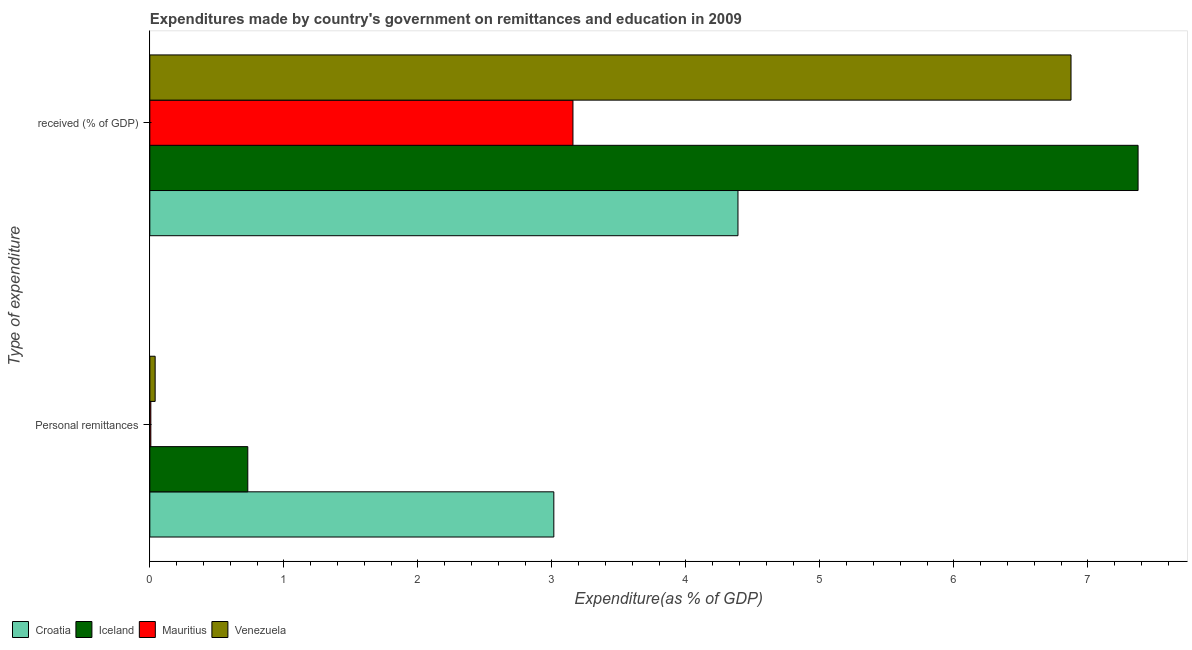How many bars are there on the 1st tick from the top?
Ensure brevity in your answer.  4. What is the label of the 2nd group of bars from the top?
Give a very brief answer. Personal remittances. What is the expenditure in education in Iceland?
Offer a very short reply. 7.38. Across all countries, what is the maximum expenditure in personal remittances?
Your answer should be compact. 3.01. Across all countries, what is the minimum expenditure in education?
Keep it short and to the point. 3.16. In which country was the expenditure in personal remittances minimum?
Provide a succinct answer. Mauritius. What is the total expenditure in education in the graph?
Provide a short and direct response. 21.8. What is the difference between the expenditure in personal remittances in Croatia and that in Venezuela?
Keep it short and to the point. 2.98. What is the difference between the expenditure in education in Croatia and the expenditure in personal remittances in Venezuela?
Make the answer very short. 4.35. What is the average expenditure in personal remittances per country?
Ensure brevity in your answer.  0.95. What is the difference between the expenditure in education and expenditure in personal remittances in Mauritius?
Make the answer very short. 3.15. In how many countries, is the expenditure in education greater than 4.2 %?
Keep it short and to the point. 3. What is the ratio of the expenditure in personal remittances in Venezuela to that in Mauritius?
Your response must be concise. 5.32. In how many countries, is the expenditure in education greater than the average expenditure in education taken over all countries?
Offer a very short reply. 2. What does the 3rd bar from the top in Personal remittances represents?
Your answer should be compact. Iceland. How many bars are there?
Your answer should be compact. 8. Are all the bars in the graph horizontal?
Ensure brevity in your answer.  Yes. Are the values on the major ticks of X-axis written in scientific E-notation?
Keep it short and to the point. No. Does the graph contain grids?
Offer a very short reply. No. Where does the legend appear in the graph?
Offer a terse response. Bottom left. How many legend labels are there?
Provide a succinct answer. 4. How are the legend labels stacked?
Offer a very short reply. Horizontal. What is the title of the graph?
Give a very brief answer. Expenditures made by country's government on remittances and education in 2009. Does "Latvia" appear as one of the legend labels in the graph?
Your answer should be compact. No. What is the label or title of the X-axis?
Keep it short and to the point. Expenditure(as % of GDP). What is the label or title of the Y-axis?
Ensure brevity in your answer.  Type of expenditure. What is the Expenditure(as % of GDP) in Croatia in Personal remittances?
Give a very brief answer. 3.01. What is the Expenditure(as % of GDP) of Iceland in Personal remittances?
Give a very brief answer. 0.73. What is the Expenditure(as % of GDP) of Mauritius in Personal remittances?
Offer a terse response. 0.01. What is the Expenditure(as % of GDP) of Venezuela in Personal remittances?
Make the answer very short. 0.04. What is the Expenditure(as % of GDP) in Croatia in  received (% of GDP)?
Offer a very short reply. 4.39. What is the Expenditure(as % of GDP) in Iceland in  received (% of GDP)?
Make the answer very short. 7.38. What is the Expenditure(as % of GDP) in Mauritius in  received (% of GDP)?
Keep it short and to the point. 3.16. What is the Expenditure(as % of GDP) in Venezuela in  received (% of GDP)?
Offer a very short reply. 6.87. Across all Type of expenditure, what is the maximum Expenditure(as % of GDP) of Croatia?
Your response must be concise. 4.39. Across all Type of expenditure, what is the maximum Expenditure(as % of GDP) of Iceland?
Make the answer very short. 7.38. Across all Type of expenditure, what is the maximum Expenditure(as % of GDP) of Mauritius?
Your answer should be compact. 3.16. Across all Type of expenditure, what is the maximum Expenditure(as % of GDP) in Venezuela?
Ensure brevity in your answer.  6.87. Across all Type of expenditure, what is the minimum Expenditure(as % of GDP) in Croatia?
Keep it short and to the point. 3.01. Across all Type of expenditure, what is the minimum Expenditure(as % of GDP) in Iceland?
Offer a terse response. 0.73. Across all Type of expenditure, what is the minimum Expenditure(as % of GDP) of Mauritius?
Your answer should be very brief. 0.01. Across all Type of expenditure, what is the minimum Expenditure(as % of GDP) in Venezuela?
Provide a succinct answer. 0.04. What is the total Expenditure(as % of GDP) in Croatia in the graph?
Keep it short and to the point. 7.4. What is the total Expenditure(as % of GDP) of Iceland in the graph?
Offer a very short reply. 8.11. What is the total Expenditure(as % of GDP) in Mauritius in the graph?
Your response must be concise. 3.17. What is the total Expenditure(as % of GDP) in Venezuela in the graph?
Ensure brevity in your answer.  6.91. What is the difference between the Expenditure(as % of GDP) in Croatia in Personal remittances and that in  received (% of GDP)?
Offer a terse response. -1.37. What is the difference between the Expenditure(as % of GDP) in Iceland in Personal remittances and that in  received (% of GDP)?
Offer a very short reply. -6.64. What is the difference between the Expenditure(as % of GDP) of Mauritius in Personal remittances and that in  received (% of GDP)?
Your answer should be very brief. -3.15. What is the difference between the Expenditure(as % of GDP) in Venezuela in Personal remittances and that in  received (% of GDP)?
Provide a succinct answer. -6.83. What is the difference between the Expenditure(as % of GDP) of Croatia in Personal remittances and the Expenditure(as % of GDP) of Iceland in  received (% of GDP)?
Make the answer very short. -4.36. What is the difference between the Expenditure(as % of GDP) in Croatia in Personal remittances and the Expenditure(as % of GDP) in Mauritius in  received (% of GDP)?
Your response must be concise. -0.14. What is the difference between the Expenditure(as % of GDP) of Croatia in Personal remittances and the Expenditure(as % of GDP) of Venezuela in  received (% of GDP)?
Ensure brevity in your answer.  -3.86. What is the difference between the Expenditure(as % of GDP) in Iceland in Personal remittances and the Expenditure(as % of GDP) in Mauritius in  received (% of GDP)?
Give a very brief answer. -2.43. What is the difference between the Expenditure(as % of GDP) of Iceland in Personal remittances and the Expenditure(as % of GDP) of Venezuela in  received (% of GDP)?
Provide a short and direct response. -6.14. What is the difference between the Expenditure(as % of GDP) of Mauritius in Personal remittances and the Expenditure(as % of GDP) of Venezuela in  received (% of GDP)?
Your answer should be very brief. -6.87. What is the average Expenditure(as % of GDP) of Croatia per Type of expenditure?
Your answer should be very brief. 3.7. What is the average Expenditure(as % of GDP) of Iceland per Type of expenditure?
Offer a terse response. 4.05. What is the average Expenditure(as % of GDP) of Mauritius per Type of expenditure?
Your answer should be compact. 1.58. What is the average Expenditure(as % of GDP) of Venezuela per Type of expenditure?
Your answer should be compact. 3.46. What is the difference between the Expenditure(as % of GDP) of Croatia and Expenditure(as % of GDP) of Iceland in Personal remittances?
Your answer should be compact. 2.28. What is the difference between the Expenditure(as % of GDP) in Croatia and Expenditure(as % of GDP) in Mauritius in Personal remittances?
Offer a very short reply. 3.01. What is the difference between the Expenditure(as % of GDP) in Croatia and Expenditure(as % of GDP) in Venezuela in Personal remittances?
Offer a terse response. 2.98. What is the difference between the Expenditure(as % of GDP) of Iceland and Expenditure(as % of GDP) of Mauritius in Personal remittances?
Ensure brevity in your answer.  0.72. What is the difference between the Expenditure(as % of GDP) in Iceland and Expenditure(as % of GDP) in Venezuela in Personal remittances?
Offer a terse response. 0.69. What is the difference between the Expenditure(as % of GDP) of Mauritius and Expenditure(as % of GDP) of Venezuela in Personal remittances?
Keep it short and to the point. -0.03. What is the difference between the Expenditure(as % of GDP) in Croatia and Expenditure(as % of GDP) in Iceland in  received (% of GDP)?
Give a very brief answer. -2.99. What is the difference between the Expenditure(as % of GDP) of Croatia and Expenditure(as % of GDP) of Mauritius in  received (% of GDP)?
Your answer should be compact. 1.23. What is the difference between the Expenditure(as % of GDP) in Croatia and Expenditure(as % of GDP) in Venezuela in  received (% of GDP)?
Make the answer very short. -2.49. What is the difference between the Expenditure(as % of GDP) of Iceland and Expenditure(as % of GDP) of Mauritius in  received (% of GDP)?
Provide a short and direct response. 4.22. What is the difference between the Expenditure(as % of GDP) of Iceland and Expenditure(as % of GDP) of Venezuela in  received (% of GDP)?
Provide a short and direct response. 0.5. What is the difference between the Expenditure(as % of GDP) of Mauritius and Expenditure(as % of GDP) of Venezuela in  received (% of GDP)?
Your answer should be very brief. -3.72. What is the ratio of the Expenditure(as % of GDP) in Croatia in Personal remittances to that in  received (% of GDP)?
Offer a very short reply. 0.69. What is the ratio of the Expenditure(as % of GDP) in Iceland in Personal remittances to that in  received (% of GDP)?
Provide a succinct answer. 0.1. What is the ratio of the Expenditure(as % of GDP) of Mauritius in Personal remittances to that in  received (% of GDP)?
Offer a terse response. 0. What is the ratio of the Expenditure(as % of GDP) in Venezuela in Personal remittances to that in  received (% of GDP)?
Your answer should be compact. 0.01. What is the difference between the highest and the second highest Expenditure(as % of GDP) in Croatia?
Make the answer very short. 1.37. What is the difference between the highest and the second highest Expenditure(as % of GDP) of Iceland?
Give a very brief answer. 6.64. What is the difference between the highest and the second highest Expenditure(as % of GDP) of Mauritius?
Your answer should be very brief. 3.15. What is the difference between the highest and the second highest Expenditure(as % of GDP) in Venezuela?
Your answer should be very brief. 6.83. What is the difference between the highest and the lowest Expenditure(as % of GDP) of Croatia?
Your response must be concise. 1.37. What is the difference between the highest and the lowest Expenditure(as % of GDP) of Iceland?
Provide a short and direct response. 6.64. What is the difference between the highest and the lowest Expenditure(as % of GDP) of Mauritius?
Make the answer very short. 3.15. What is the difference between the highest and the lowest Expenditure(as % of GDP) of Venezuela?
Your response must be concise. 6.83. 